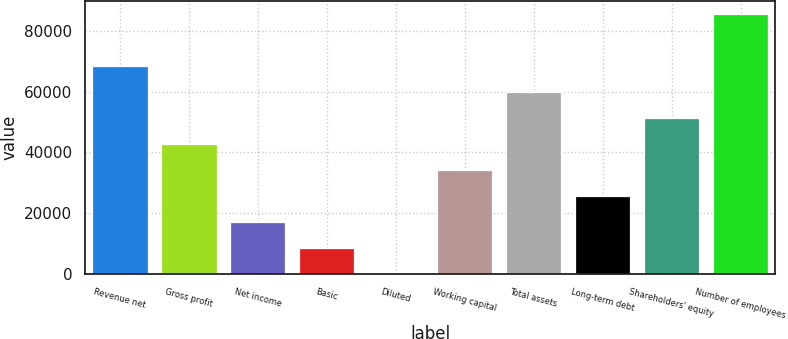Convert chart to OTSL. <chart><loc_0><loc_0><loc_500><loc_500><bar_chart><fcel>Revenue net<fcel>Gross profit<fcel>Net income<fcel>Basic<fcel>Diluted<fcel>Working capital<fcel>Total assets<fcel>Long-term debt<fcel>Shareholders' equity<fcel>Number of employees<nl><fcel>68622.4<fcel>42890.5<fcel>17158.6<fcel>8581.28<fcel>3.98<fcel>34313.2<fcel>60045.1<fcel>25735.9<fcel>51467.8<fcel>85777<nl></chart> 